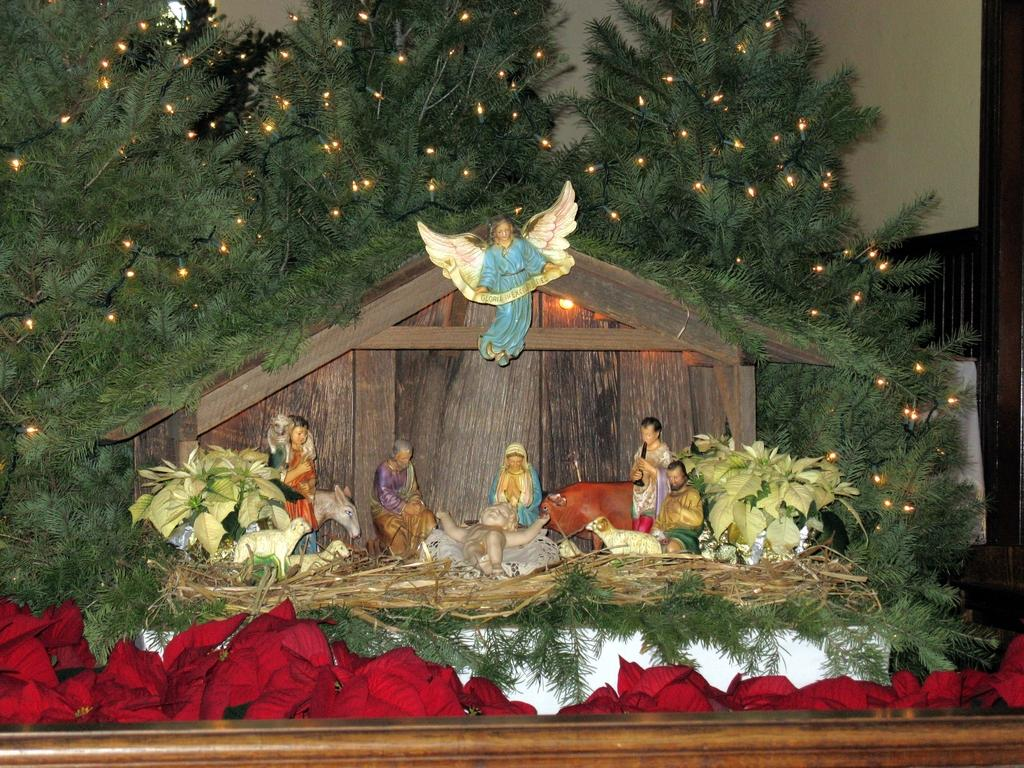What can be seen in the foreground of the image? In the foreground of the image, there are many toys, plants, and trees with lights. What is the relationship between the trees and the hut in the image? The trees are near a hut in the image. What type of flowers are present at the bottom of the image? There are red colored flowers at the bottom of the image. What can be seen in the background of the image? There is a wall in the background of the image. How many bulbs are used to light up the trees in the image? There is no information about the number of bulbs used to light up the trees in the image. What type of mitten is being used by the person in the image? There is no person or mitten present in the image. 